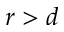Convert formula to latex. <formula><loc_0><loc_0><loc_500><loc_500>r > d</formula> 